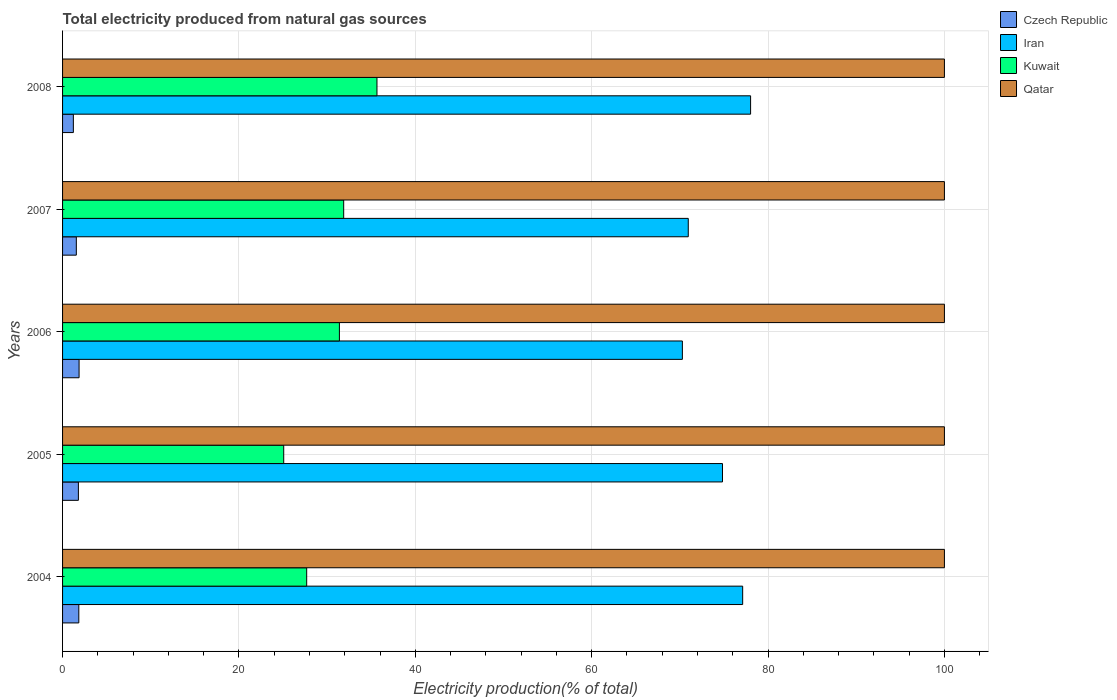How many different coloured bars are there?
Make the answer very short. 4. Are the number of bars per tick equal to the number of legend labels?
Give a very brief answer. Yes. How many bars are there on the 5th tick from the bottom?
Your answer should be compact. 4. What is the label of the 2nd group of bars from the top?
Your answer should be very brief. 2007. In how many cases, is the number of bars for a given year not equal to the number of legend labels?
Provide a short and direct response. 0. Across all years, what is the maximum total electricity produced in Iran?
Your answer should be compact. 78.02. Across all years, what is the minimum total electricity produced in Kuwait?
Keep it short and to the point. 25.08. What is the total total electricity produced in Czech Republic in the graph?
Offer a very short reply. 8.29. What is the difference between the total electricity produced in Czech Republic in 2005 and that in 2007?
Your response must be concise. 0.23. What is the difference between the total electricity produced in Kuwait in 2004 and the total electricity produced in Iran in 2007?
Your response must be concise. -43.27. What is the average total electricity produced in Czech Republic per year?
Offer a very short reply. 1.66. In the year 2005, what is the difference between the total electricity produced in Iran and total electricity produced in Kuwait?
Keep it short and to the point. 49.75. What is the ratio of the total electricity produced in Iran in 2005 to that in 2008?
Ensure brevity in your answer.  0.96. What is the difference between the highest and the second highest total electricity produced in Qatar?
Make the answer very short. 0. Is the sum of the total electricity produced in Kuwait in 2006 and 2008 greater than the maximum total electricity produced in Qatar across all years?
Your answer should be compact. No. What does the 2nd bar from the top in 2007 represents?
Keep it short and to the point. Kuwait. What does the 4th bar from the bottom in 2007 represents?
Ensure brevity in your answer.  Qatar. Is it the case that in every year, the sum of the total electricity produced in Iran and total electricity produced in Kuwait is greater than the total electricity produced in Qatar?
Offer a terse response. No. How many bars are there?
Ensure brevity in your answer.  20. How many years are there in the graph?
Make the answer very short. 5. Does the graph contain any zero values?
Your answer should be compact. No. Where does the legend appear in the graph?
Your response must be concise. Top right. How are the legend labels stacked?
Provide a short and direct response. Vertical. What is the title of the graph?
Provide a succinct answer. Total electricity produced from natural gas sources. Does "Pakistan" appear as one of the legend labels in the graph?
Keep it short and to the point. No. What is the label or title of the X-axis?
Give a very brief answer. Electricity production(% of total). What is the Electricity production(% of total) in Czech Republic in 2004?
Your response must be concise. 1.84. What is the Electricity production(% of total) of Iran in 2004?
Ensure brevity in your answer.  77.12. What is the Electricity production(% of total) in Kuwait in 2004?
Give a very brief answer. 27.68. What is the Electricity production(% of total) in Qatar in 2004?
Your response must be concise. 100. What is the Electricity production(% of total) in Czech Republic in 2005?
Give a very brief answer. 1.79. What is the Electricity production(% of total) of Iran in 2005?
Offer a terse response. 74.83. What is the Electricity production(% of total) in Kuwait in 2005?
Provide a short and direct response. 25.08. What is the Electricity production(% of total) of Czech Republic in 2006?
Provide a short and direct response. 1.87. What is the Electricity production(% of total) in Iran in 2006?
Your answer should be compact. 70.29. What is the Electricity production(% of total) in Kuwait in 2006?
Your answer should be compact. 31.39. What is the Electricity production(% of total) in Czech Republic in 2007?
Your answer should be compact. 1.56. What is the Electricity production(% of total) of Iran in 2007?
Make the answer very short. 70.95. What is the Electricity production(% of total) of Kuwait in 2007?
Give a very brief answer. 31.88. What is the Electricity production(% of total) of Qatar in 2007?
Offer a very short reply. 100. What is the Electricity production(% of total) of Czech Republic in 2008?
Keep it short and to the point. 1.22. What is the Electricity production(% of total) of Iran in 2008?
Keep it short and to the point. 78.02. What is the Electricity production(% of total) in Kuwait in 2008?
Your response must be concise. 35.65. Across all years, what is the maximum Electricity production(% of total) in Czech Republic?
Your response must be concise. 1.87. Across all years, what is the maximum Electricity production(% of total) in Iran?
Your answer should be compact. 78.02. Across all years, what is the maximum Electricity production(% of total) of Kuwait?
Provide a short and direct response. 35.65. Across all years, what is the minimum Electricity production(% of total) of Czech Republic?
Provide a short and direct response. 1.22. Across all years, what is the minimum Electricity production(% of total) of Iran?
Keep it short and to the point. 70.29. Across all years, what is the minimum Electricity production(% of total) of Kuwait?
Offer a very short reply. 25.08. Across all years, what is the minimum Electricity production(% of total) in Qatar?
Make the answer very short. 100. What is the total Electricity production(% of total) in Czech Republic in the graph?
Ensure brevity in your answer.  8.29. What is the total Electricity production(% of total) in Iran in the graph?
Give a very brief answer. 371.22. What is the total Electricity production(% of total) of Kuwait in the graph?
Your answer should be very brief. 151.69. What is the difference between the Electricity production(% of total) of Czech Republic in 2004 and that in 2005?
Make the answer very short. 0.05. What is the difference between the Electricity production(% of total) of Iran in 2004 and that in 2005?
Make the answer very short. 2.29. What is the difference between the Electricity production(% of total) in Kuwait in 2004 and that in 2005?
Make the answer very short. 2.6. What is the difference between the Electricity production(% of total) of Czech Republic in 2004 and that in 2006?
Offer a terse response. -0.03. What is the difference between the Electricity production(% of total) of Iran in 2004 and that in 2006?
Provide a short and direct response. 6.84. What is the difference between the Electricity production(% of total) in Kuwait in 2004 and that in 2006?
Provide a short and direct response. -3.71. What is the difference between the Electricity production(% of total) in Qatar in 2004 and that in 2006?
Your response must be concise. 0. What is the difference between the Electricity production(% of total) in Czech Republic in 2004 and that in 2007?
Your answer should be compact. 0.28. What is the difference between the Electricity production(% of total) in Iran in 2004 and that in 2007?
Offer a terse response. 6.17. What is the difference between the Electricity production(% of total) of Kuwait in 2004 and that in 2007?
Give a very brief answer. -4.2. What is the difference between the Electricity production(% of total) in Czech Republic in 2004 and that in 2008?
Your response must be concise. 0.62. What is the difference between the Electricity production(% of total) in Iran in 2004 and that in 2008?
Give a very brief answer. -0.9. What is the difference between the Electricity production(% of total) of Kuwait in 2004 and that in 2008?
Your response must be concise. -7.97. What is the difference between the Electricity production(% of total) in Qatar in 2004 and that in 2008?
Provide a short and direct response. 0. What is the difference between the Electricity production(% of total) in Czech Republic in 2005 and that in 2006?
Provide a short and direct response. -0.08. What is the difference between the Electricity production(% of total) in Iran in 2005 and that in 2006?
Offer a very short reply. 4.55. What is the difference between the Electricity production(% of total) in Kuwait in 2005 and that in 2006?
Ensure brevity in your answer.  -6.31. What is the difference between the Electricity production(% of total) of Czech Republic in 2005 and that in 2007?
Provide a succinct answer. 0.23. What is the difference between the Electricity production(% of total) in Iran in 2005 and that in 2007?
Give a very brief answer. 3.88. What is the difference between the Electricity production(% of total) of Kuwait in 2005 and that in 2007?
Ensure brevity in your answer.  -6.8. What is the difference between the Electricity production(% of total) of Czech Republic in 2005 and that in 2008?
Make the answer very short. 0.57. What is the difference between the Electricity production(% of total) of Iran in 2005 and that in 2008?
Make the answer very short. -3.19. What is the difference between the Electricity production(% of total) in Kuwait in 2005 and that in 2008?
Ensure brevity in your answer.  -10.57. What is the difference between the Electricity production(% of total) in Czech Republic in 2006 and that in 2007?
Provide a short and direct response. 0.31. What is the difference between the Electricity production(% of total) of Iran in 2006 and that in 2007?
Provide a succinct answer. -0.67. What is the difference between the Electricity production(% of total) in Kuwait in 2006 and that in 2007?
Provide a short and direct response. -0.49. What is the difference between the Electricity production(% of total) in Czech Republic in 2006 and that in 2008?
Give a very brief answer. 0.65. What is the difference between the Electricity production(% of total) in Iran in 2006 and that in 2008?
Provide a short and direct response. -7.73. What is the difference between the Electricity production(% of total) of Kuwait in 2006 and that in 2008?
Your response must be concise. -4.26. What is the difference between the Electricity production(% of total) in Qatar in 2006 and that in 2008?
Ensure brevity in your answer.  0. What is the difference between the Electricity production(% of total) in Czech Republic in 2007 and that in 2008?
Offer a terse response. 0.34. What is the difference between the Electricity production(% of total) of Iran in 2007 and that in 2008?
Offer a very short reply. -7.07. What is the difference between the Electricity production(% of total) in Kuwait in 2007 and that in 2008?
Make the answer very short. -3.77. What is the difference between the Electricity production(% of total) in Czech Republic in 2004 and the Electricity production(% of total) in Iran in 2005?
Your answer should be very brief. -72.99. What is the difference between the Electricity production(% of total) of Czech Republic in 2004 and the Electricity production(% of total) of Kuwait in 2005?
Offer a very short reply. -23.24. What is the difference between the Electricity production(% of total) in Czech Republic in 2004 and the Electricity production(% of total) in Qatar in 2005?
Provide a succinct answer. -98.16. What is the difference between the Electricity production(% of total) of Iran in 2004 and the Electricity production(% of total) of Kuwait in 2005?
Make the answer very short. 52.04. What is the difference between the Electricity production(% of total) of Iran in 2004 and the Electricity production(% of total) of Qatar in 2005?
Provide a succinct answer. -22.88. What is the difference between the Electricity production(% of total) of Kuwait in 2004 and the Electricity production(% of total) of Qatar in 2005?
Give a very brief answer. -72.32. What is the difference between the Electricity production(% of total) in Czech Republic in 2004 and the Electricity production(% of total) in Iran in 2006?
Make the answer very short. -68.44. What is the difference between the Electricity production(% of total) of Czech Republic in 2004 and the Electricity production(% of total) of Kuwait in 2006?
Provide a succinct answer. -29.55. What is the difference between the Electricity production(% of total) of Czech Republic in 2004 and the Electricity production(% of total) of Qatar in 2006?
Your response must be concise. -98.16. What is the difference between the Electricity production(% of total) in Iran in 2004 and the Electricity production(% of total) in Kuwait in 2006?
Make the answer very short. 45.73. What is the difference between the Electricity production(% of total) in Iran in 2004 and the Electricity production(% of total) in Qatar in 2006?
Your answer should be very brief. -22.88. What is the difference between the Electricity production(% of total) in Kuwait in 2004 and the Electricity production(% of total) in Qatar in 2006?
Offer a terse response. -72.32. What is the difference between the Electricity production(% of total) of Czech Republic in 2004 and the Electricity production(% of total) of Iran in 2007?
Your answer should be very brief. -69.11. What is the difference between the Electricity production(% of total) in Czech Republic in 2004 and the Electricity production(% of total) in Kuwait in 2007?
Your response must be concise. -30.04. What is the difference between the Electricity production(% of total) in Czech Republic in 2004 and the Electricity production(% of total) in Qatar in 2007?
Keep it short and to the point. -98.16. What is the difference between the Electricity production(% of total) of Iran in 2004 and the Electricity production(% of total) of Kuwait in 2007?
Offer a terse response. 45.24. What is the difference between the Electricity production(% of total) in Iran in 2004 and the Electricity production(% of total) in Qatar in 2007?
Provide a short and direct response. -22.88. What is the difference between the Electricity production(% of total) of Kuwait in 2004 and the Electricity production(% of total) of Qatar in 2007?
Keep it short and to the point. -72.32. What is the difference between the Electricity production(% of total) in Czech Republic in 2004 and the Electricity production(% of total) in Iran in 2008?
Your response must be concise. -76.18. What is the difference between the Electricity production(% of total) of Czech Republic in 2004 and the Electricity production(% of total) of Kuwait in 2008?
Make the answer very short. -33.81. What is the difference between the Electricity production(% of total) in Czech Republic in 2004 and the Electricity production(% of total) in Qatar in 2008?
Your response must be concise. -98.16. What is the difference between the Electricity production(% of total) in Iran in 2004 and the Electricity production(% of total) in Kuwait in 2008?
Your answer should be very brief. 41.47. What is the difference between the Electricity production(% of total) of Iran in 2004 and the Electricity production(% of total) of Qatar in 2008?
Make the answer very short. -22.88. What is the difference between the Electricity production(% of total) of Kuwait in 2004 and the Electricity production(% of total) of Qatar in 2008?
Give a very brief answer. -72.32. What is the difference between the Electricity production(% of total) in Czech Republic in 2005 and the Electricity production(% of total) in Iran in 2006?
Your answer should be compact. -68.49. What is the difference between the Electricity production(% of total) of Czech Republic in 2005 and the Electricity production(% of total) of Kuwait in 2006?
Provide a succinct answer. -29.6. What is the difference between the Electricity production(% of total) of Czech Republic in 2005 and the Electricity production(% of total) of Qatar in 2006?
Your answer should be compact. -98.21. What is the difference between the Electricity production(% of total) in Iran in 2005 and the Electricity production(% of total) in Kuwait in 2006?
Your answer should be compact. 43.44. What is the difference between the Electricity production(% of total) in Iran in 2005 and the Electricity production(% of total) in Qatar in 2006?
Keep it short and to the point. -25.17. What is the difference between the Electricity production(% of total) of Kuwait in 2005 and the Electricity production(% of total) of Qatar in 2006?
Your answer should be very brief. -74.92. What is the difference between the Electricity production(% of total) of Czech Republic in 2005 and the Electricity production(% of total) of Iran in 2007?
Provide a succinct answer. -69.16. What is the difference between the Electricity production(% of total) in Czech Republic in 2005 and the Electricity production(% of total) in Kuwait in 2007?
Ensure brevity in your answer.  -30.08. What is the difference between the Electricity production(% of total) of Czech Republic in 2005 and the Electricity production(% of total) of Qatar in 2007?
Offer a terse response. -98.21. What is the difference between the Electricity production(% of total) in Iran in 2005 and the Electricity production(% of total) in Kuwait in 2007?
Your answer should be compact. 42.95. What is the difference between the Electricity production(% of total) in Iran in 2005 and the Electricity production(% of total) in Qatar in 2007?
Keep it short and to the point. -25.17. What is the difference between the Electricity production(% of total) of Kuwait in 2005 and the Electricity production(% of total) of Qatar in 2007?
Offer a terse response. -74.92. What is the difference between the Electricity production(% of total) in Czech Republic in 2005 and the Electricity production(% of total) in Iran in 2008?
Provide a short and direct response. -76.23. What is the difference between the Electricity production(% of total) in Czech Republic in 2005 and the Electricity production(% of total) in Kuwait in 2008?
Give a very brief answer. -33.86. What is the difference between the Electricity production(% of total) of Czech Republic in 2005 and the Electricity production(% of total) of Qatar in 2008?
Offer a very short reply. -98.21. What is the difference between the Electricity production(% of total) of Iran in 2005 and the Electricity production(% of total) of Kuwait in 2008?
Your response must be concise. 39.18. What is the difference between the Electricity production(% of total) in Iran in 2005 and the Electricity production(% of total) in Qatar in 2008?
Keep it short and to the point. -25.17. What is the difference between the Electricity production(% of total) in Kuwait in 2005 and the Electricity production(% of total) in Qatar in 2008?
Make the answer very short. -74.92. What is the difference between the Electricity production(% of total) in Czech Republic in 2006 and the Electricity production(% of total) in Iran in 2007?
Make the answer very short. -69.08. What is the difference between the Electricity production(% of total) in Czech Republic in 2006 and the Electricity production(% of total) in Kuwait in 2007?
Offer a very short reply. -30.01. What is the difference between the Electricity production(% of total) of Czech Republic in 2006 and the Electricity production(% of total) of Qatar in 2007?
Ensure brevity in your answer.  -98.13. What is the difference between the Electricity production(% of total) in Iran in 2006 and the Electricity production(% of total) in Kuwait in 2007?
Make the answer very short. 38.41. What is the difference between the Electricity production(% of total) in Iran in 2006 and the Electricity production(% of total) in Qatar in 2007?
Offer a very short reply. -29.71. What is the difference between the Electricity production(% of total) of Kuwait in 2006 and the Electricity production(% of total) of Qatar in 2007?
Keep it short and to the point. -68.61. What is the difference between the Electricity production(% of total) of Czech Republic in 2006 and the Electricity production(% of total) of Iran in 2008?
Your answer should be compact. -76.15. What is the difference between the Electricity production(% of total) in Czech Republic in 2006 and the Electricity production(% of total) in Kuwait in 2008?
Provide a succinct answer. -33.78. What is the difference between the Electricity production(% of total) of Czech Republic in 2006 and the Electricity production(% of total) of Qatar in 2008?
Keep it short and to the point. -98.13. What is the difference between the Electricity production(% of total) of Iran in 2006 and the Electricity production(% of total) of Kuwait in 2008?
Provide a succinct answer. 34.63. What is the difference between the Electricity production(% of total) in Iran in 2006 and the Electricity production(% of total) in Qatar in 2008?
Your answer should be very brief. -29.71. What is the difference between the Electricity production(% of total) of Kuwait in 2006 and the Electricity production(% of total) of Qatar in 2008?
Offer a terse response. -68.61. What is the difference between the Electricity production(% of total) of Czech Republic in 2007 and the Electricity production(% of total) of Iran in 2008?
Your answer should be compact. -76.46. What is the difference between the Electricity production(% of total) in Czech Republic in 2007 and the Electricity production(% of total) in Kuwait in 2008?
Your answer should be compact. -34.09. What is the difference between the Electricity production(% of total) of Czech Republic in 2007 and the Electricity production(% of total) of Qatar in 2008?
Keep it short and to the point. -98.44. What is the difference between the Electricity production(% of total) of Iran in 2007 and the Electricity production(% of total) of Kuwait in 2008?
Offer a terse response. 35.3. What is the difference between the Electricity production(% of total) in Iran in 2007 and the Electricity production(% of total) in Qatar in 2008?
Provide a short and direct response. -29.05. What is the difference between the Electricity production(% of total) in Kuwait in 2007 and the Electricity production(% of total) in Qatar in 2008?
Your answer should be compact. -68.12. What is the average Electricity production(% of total) of Czech Republic per year?
Your response must be concise. 1.66. What is the average Electricity production(% of total) of Iran per year?
Give a very brief answer. 74.24. What is the average Electricity production(% of total) of Kuwait per year?
Give a very brief answer. 30.34. What is the average Electricity production(% of total) in Qatar per year?
Give a very brief answer. 100. In the year 2004, what is the difference between the Electricity production(% of total) of Czech Republic and Electricity production(% of total) of Iran?
Make the answer very short. -75.28. In the year 2004, what is the difference between the Electricity production(% of total) of Czech Republic and Electricity production(% of total) of Kuwait?
Your answer should be compact. -25.84. In the year 2004, what is the difference between the Electricity production(% of total) in Czech Republic and Electricity production(% of total) in Qatar?
Give a very brief answer. -98.16. In the year 2004, what is the difference between the Electricity production(% of total) in Iran and Electricity production(% of total) in Kuwait?
Your answer should be very brief. 49.44. In the year 2004, what is the difference between the Electricity production(% of total) of Iran and Electricity production(% of total) of Qatar?
Give a very brief answer. -22.88. In the year 2004, what is the difference between the Electricity production(% of total) of Kuwait and Electricity production(% of total) of Qatar?
Ensure brevity in your answer.  -72.32. In the year 2005, what is the difference between the Electricity production(% of total) of Czech Republic and Electricity production(% of total) of Iran?
Your response must be concise. -73.04. In the year 2005, what is the difference between the Electricity production(% of total) in Czech Republic and Electricity production(% of total) in Kuwait?
Your answer should be compact. -23.28. In the year 2005, what is the difference between the Electricity production(% of total) of Czech Republic and Electricity production(% of total) of Qatar?
Offer a very short reply. -98.21. In the year 2005, what is the difference between the Electricity production(% of total) of Iran and Electricity production(% of total) of Kuwait?
Your response must be concise. 49.75. In the year 2005, what is the difference between the Electricity production(% of total) of Iran and Electricity production(% of total) of Qatar?
Give a very brief answer. -25.17. In the year 2005, what is the difference between the Electricity production(% of total) in Kuwait and Electricity production(% of total) in Qatar?
Provide a short and direct response. -74.92. In the year 2006, what is the difference between the Electricity production(% of total) of Czech Republic and Electricity production(% of total) of Iran?
Your response must be concise. -68.41. In the year 2006, what is the difference between the Electricity production(% of total) in Czech Republic and Electricity production(% of total) in Kuwait?
Provide a short and direct response. -29.52. In the year 2006, what is the difference between the Electricity production(% of total) of Czech Republic and Electricity production(% of total) of Qatar?
Your answer should be very brief. -98.13. In the year 2006, what is the difference between the Electricity production(% of total) in Iran and Electricity production(% of total) in Kuwait?
Give a very brief answer. 38.89. In the year 2006, what is the difference between the Electricity production(% of total) of Iran and Electricity production(% of total) of Qatar?
Offer a terse response. -29.71. In the year 2006, what is the difference between the Electricity production(% of total) in Kuwait and Electricity production(% of total) in Qatar?
Keep it short and to the point. -68.61. In the year 2007, what is the difference between the Electricity production(% of total) in Czech Republic and Electricity production(% of total) in Iran?
Your response must be concise. -69.39. In the year 2007, what is the difference between the Electricity production(% of total) of Czech Republic and Electricity production(% of total) of Kuwait?
Provide a succinct answer. -30.32. In the year 2007, what is the difference between the Electricity production(% of total) of Czech Republic and Electricity production(% of total) of Qatar?
Give a very brief answer. -98.44. In the year 2007, what is the difference between the Electricity production(% of total) of Iran and Electricity production(% of total) of Kuwait?
Provide a short and direct response. 39.07. In the year 2007, what is the difference between the Electricity production(% of total) of Iran and Electricity production(% of total) of Qatar?
Your answer should be very brief. -29.05. In the year 2007, what is the difference between the Electricity production(% of total) of Kuwait and Electricity production(% of total) of Qatar?
Your response must be concise. -68.12. In the year 2008, what is the difference between the Electricity production(% of total) of Czech Republic and Electricity production(% of total) of Iran?
Your answer should be compact. -76.8. In the year 2008, what is the difference between the Electricity production(% of total) in Czech Republic and Electricity production(% of total) in Kuwait?
Give a very brief answer. -34.43. In the year 2008, what is the difference between the Electricity production(% of total) of Czech Republic and Electricity production(% of total) of Qatar?
Provide a succinct answer. -98.78. In the year 2008, what is the difference between the Electricity production(% of total) in Iran and Electricity production(% of total) in Kuwait?
Ensure brevity in your answer.  42.37. In the year 2008, what is the difference between the Electricity production(% of total) of Iran and Electricity production(% of total) of Qatar?
Offer a very short reply. -21.98. In the year 2008, what is the difference between the Electricity production(% of total) in Kuwait and Electricity production(% of total) in Qatar?
Offer a terse response. -64.35. What is the ratio of the Electricity production(% of total) of Czech Republic in 2004 to that in 2005?
Your response must be concise. 1.03. What is the ratio of the Electricity production(% of total) in Iran in 2004 to that in 2005?
Ensure brevity in your answer.  1.03. What is the ratio of the Electricity production(% of total) of Kuwait in 2004 to that in 2005?
Provide a succinct answer. 1.1. What is the ratio of the Electricity production(% of total) in Czech Republic in 2004 to that in 2006?
Provide a succinct answer. 0.98. What is the ratio of the Electricity production(% of total) of Iran in 2004 to that in 2006?
Ensure brevity in your answer.  1.1. What is the ratio of the Electricity production(% of total) in Kuwait in 2004 to that in 2006?
Offer a terse response. 0.88. What is the ratio of the Electricity production(% of total) in Czech Republic in 2004 to that in 2007?
Ensure brevity in your answer.  1.18. What is the ratio of the Electricity production(% of total) in Iran in 2004 to that in 2007?
Provide a short and direct response. 1.09. What is the ratio of the Electricity production(% of total) of Kuwait in 2004 to that in 2007?
Make the answer very short. 0.87. What is the ratio of the Electricity production(% of total) in Qatar in 2004 to that in 2007?
Your answer should be compact. 1. What is the ratio of the Electricity production(% of total) of Czech Republic in 2004 to that in 2008?
Offer a very short reply. 1.5. What is the ratio of the Electricity production(% of total) in Iran in 2004 to that in 2008?
Offer a terse response. 0.99. What is the ratio of the Electricity production(% of total) of Kuwait in 2004 to that in 2008?
Keep it short and to the point. 0.78. What is the ratio of the Electricity production(% of total) in Czech Republic in 2005 to that in 2006?
Provide a short and direct response. 0.96. What is the ratio of the Electricity production(% of total) in Iran in 2005 to that in 2006?
Give a very brief answer. 1.06. What is the ratio of the Electricity production(% of total) of Kuwait in 2005 to that in 2006?
Offer a terse response. 0.8. What is the ratio of the Electricity production(% of total) in Czech Republic in 2005 to that in 2007?
Offer a very short reply. 1.15. What is the ratio of the Electricity production(% of total) of Iran in 2005 to that in 2007?
Provide a short and direct response. 1.05. What is the ratio of the Electricity production(% of total) of Kuwait in 2005 to that in 2007?
Your answer should be compact. 0.79. What is the ratio of the Electricity production(% of total) of Qatar in 2005 to that in 2007?
Your answer should be compact. 1. What is the ratio of the Electricity production(% of total) of Czech Republic in 2005 to that in 2008?
Offer a terse response. 1.47. What is the ratio of the Electricity production(% of total) of Iran in 2005 to that in 2008?
Your answer should be very brief. 0.96. What is the ratio of the Electricity production(% of total) of Kuwait in 2005 to that in 2008?
Offer a terse response. 0.7. What is the ratio of the Electricity production(% of total) of Qatar in 2005 to that in 2008?
Offer a terse response. 1. What is the ratio of the Electricity production(% of total) of Czech Republic in 2006 to that in 2007?
Offer a terse response. 1.2. What is the ratio of the Electricity production(% of total) in Iran in 2006 to that in 2007?
Make the answer very short. 0.99. What is the ratio of the Electricity production(% of total) of Kuwait in 2006 to that in 2007?
Keep it short and to the point. 0.98. What is the ratio of the Electricity production(% of total) of Czech Republic in 2006 to that in 2008?
Your answer should be very brief. 1.53. What is the ratio of the Electricity production(% of total) in Iran in 2006 to that in 2008?
Offer a very short reply. 0.9. What is the ratio of the Electricity production(% of total) of Kuwait in 2006 to that in 2008?
Offer a very short reply. 0.88. What is the ratio of the Electricity production(% of total) in Czech Republic in 2007 to that in 2008?
Your response must be concise. 1.28. What is the ratio of the Electricity production(% of total) in Iran in 2007 to that in 2008?
Offer a terse response. 0.91. What is the ratio of the Electricity production(% of total) in Kuwait in 2007 to that in 2008?
Ensure brevity in your answer.  0.89. What is the ratio of the Electricity production(% of total) in Qatar in 2007 to that in 2008?
Offer a very short reply. 1. What is the difference between the highest and the second highest Electricity production(% of total) of Czech Republic?
Keep it short and to the point. 0.03. What is the difference between the highest and the second highest Electricity production(% of total) in Iran?
Your answer should be compact. 0.9. What is the difference between the highest and the second highest Electricity production(% of total) in Kuwait?
Give a very brief answer. 3.77. What is the difference between the highest and the second highest Electricity production(% of total) in Qatar?
Ensure brevity in your answer.  0. What is the difference between the highest and the lowest Electricity production(% of total) of Czech Republic?
Ensure brevity in your answer.  0.65. What is the difference between the highest and the lowest Electricity production(% of total) of Iran?
Offer a very short reply. 7.73. What is the difference between the highest and the lowest Electricity production(% of total) of Kuwait?
Give a very brief answer. 10.57. What is the difference between the highest and the lowest Electricity production(% of total) in Qatar?
Offer a terse response. 0. 